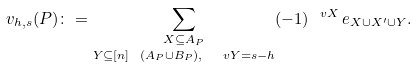Convert formula to latex. <formula><loc_0><loc_0><loc_500><loc_500>v _ { h , s } ( P ) \colon = \underset { Y \subseteq [ n ] \ ( A _ { P } \cup B _ { P } ) , \ \ v { Y } = s - h } { \sum _ { X \subseteq A _ { P } } } ( - 1 ) ^ { \ v { X } } \, e _ { X \cup X ^ { \prime } \cup Y } .</formula> 